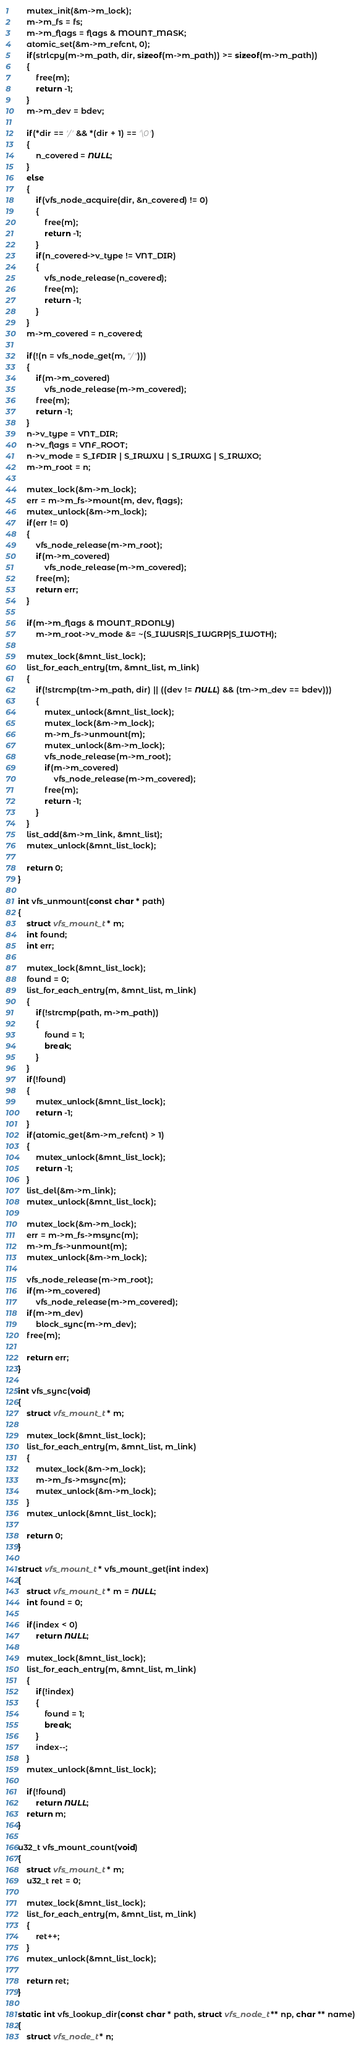Convert code to text. <code><loc_0><loc_0><loc_500><loc_500><_C_>	mutex_init(&m->m_lock);
	m->m_fs = fs;
	m->m_flags = flags & MOUNT_MASK;
	atomic_set(&m->m_refcnt, 0);
	if(strlcpy(m->m_path, dir, sizeof(m->m_path)) >= sizeof(m->m_path))
	{
		free(m);
		return -1;
	}
	m->m_dev = bdev;

	if(*dir == '/' && *(dir + 1) == '\0')
	{
		n_covered = NULL;
	}
	else
	{
		if(vfs_node_acquire(dir, &n_covered) != 0)
		{
			free(m);
			return -1;
		}
		if(n_covered->v_type != VNT_DIR)
		{
			vfs_node_release(n_covered);
			free(m);
			return -1;
		}
	}
	m->m_covered = n_covered;

	if(!(n = vfs_node_get(m, "/")))
	{
		if(m->m_covered)
			vfs_node_release(m->m_covered);
		free(m);
		return -1;
	}
	n->v_type = VNT_DIR;
	n->v_flags = VNF_ROOT;
	n->v_mode = S_IFDIR | S_IRWXU | S_IRWXG | S_IRWXO;
	m->m_root = n;

	mutex_lock(&m->m_lock);
	err = m->m_fs->mount(m, dev, flags);
	mutex_unlock(&m->m_lock);
	if(err != 0)
	{
		vfs_node_release(m->m_root);
		if(m->m_covered)
			vfs_node_release(m->m_covered);
		free(m);
		return err;
	}

	if(m->m_flags & MOUNT_RDONLY)
		m->m_root->v_mode &= ~(S_IWUSR|S_IWGRP|S_IWOTH);

	mutex_lock(&mnt_list_lock);
	list_for_each_entry(tm, &mnt_list, m_link)
	{
		if(!strcmp(tm->m_path, dir) || ((dev != NULL) && (tm->m_dev == bdev)))
		{
			mutex_unlock(&mnt_list_lock);
			mutex_lock(&m->m_lock);
			m->m_fs->unmount(m);
			mutex_unlock(&m->m_lock);
			vfs_node_release(m->m_root);
			if(m->m_covered)
				vfs_node_release(m->m_covered);
			free(m);
			return -1;
		}
	}
	list_add(&m->m_link, &mnt_list);
	mutex_unlock(&mnt_list_lock);

	return 0;
}

int vfs_unmount(const char * path)
{
	struct vfs_mount_t * m;
	int found;
	int err;

	mutex_lock(&mnt_list_lock);
	found = 0;
	list_for_each_entry(m, &mnt_list, m_link)
	{
		if(!strcmp(path, m->m_path))
		{
			found = 1;
			break;
		}
	}
	if(!found)
	{
		mutex_unlock(&mnt_list_lock);
		return -1;
	}
	if(atomic_get(&m->m_refcnt) > 1)
	{
		mutex_unlock(&mnt_list_lock);
		return -1;
	}
	list_del(&m->m_link);
	mutex_unlock(&mnt_list_lock);

	mutex_lock(&m->m_lock);
	err = m->m_fs->msync(m);
	m->m_fs->unmount(m);
	mutex_unlock(&m->m_lock);

	vfs_node_release(m->m_root);
	if(m->m_covered)
		vfs_node_release(m->m_covered);
	if(m->m_dev)
		block_sync(m->m_dev);
	free(m);

	return err;
}

int vfs_sync(void)
{
	struct vfs_mount_t * m;

	mutex_lock(&mnt_list_lock);
	list_for_each_entry(m, &mnt_list, m_link)
	{
		mutex_lock(&m->m_lock);
		m->m_fs->msync(m);
		mutex_unlock(&m->m_lock);
	}
	mutex_unlock(&mnt_list_lock);

	return 0;
}

struct vfs_mount_t * vfs_mount_get(int index)
{
	struct vfs_mount_t * m = NULL;
	int found = 0;

	if(index < 0)
		return NULL;

	mutex_lock(&mnt_list_lock);
	list_for_each_entry(m, &mnt_list, m_link)
	{
		if(!index)
		{
			found = 1;
			break;
		}
		index--;
	}
	mutex_unlock(&mnt_list_lock);

	if(!found)
		return NULL;
	return m;
}

u32_t vfs_mount_count(void)
{
	struct vfs_mount_t * m;
	u32_t ret = 0;

	mutex_lock(&mnt_list_lock);
	list_for_each_entry(m, &mnt_list, m_link)
	{
		ret++;
	}
	mutex_unlock(&mnt_list_lock);

	return ret;
}

static int vfs_lookup_dir(const char * path, struct vfs_node_t ** np, char ** name)
{
	struct vfs_node_t * n;</code> 